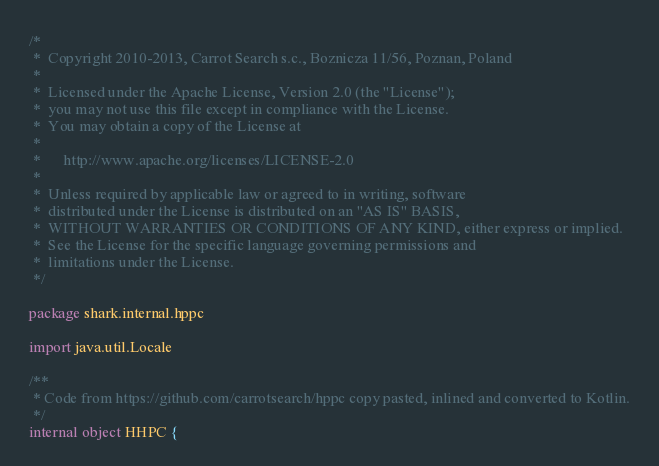Convert code to text. <code><loc_0><loc_0><loc_500><loc_500><_Kotlin_>/*
 *  Copyright 2010-2013, Carrot Search s.c., Boznicza 11/56, Poznan, Poland
 *
 *  Licensed under the Apache License, Version 2.0 (the "License");
 *  you may not use this file except in compliance with the License.
 *  You may obtain a copy of the License at
 *
 *      http://www.apache.org/licenses/LICENSE-2.0
 *
 *  Unless required by applicable law or agreed to in writing, software
 *  distributed under the License is distributed on an "AS IS" BASIS,
 *  WITHOUT WARRANTIES OR CONDITIONS OF ANY KIND, either express or implied.
 *  See the License for the specific language governing permissions and
 *  limitations under the License.
 */

package shark.internal.hppc

import java.util.Locale

/**
 * Code from https://github.com/carrotsearch/hppc copy pasted, inlined and converted to Kotlin.
 */
internal object HHPC {
</code> 